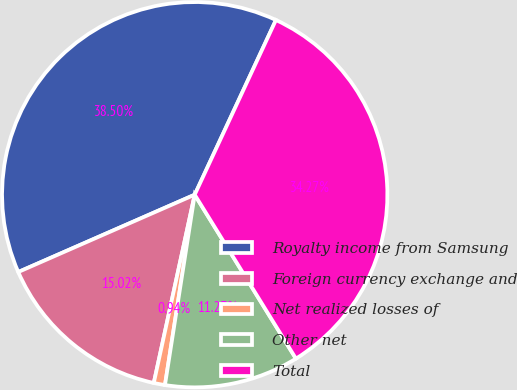Convert chart. <chart><loc_0><loc_0><loc_500><loc_500><pie_chart><fcel>Royalty income from Samsung<fcel>Foreign currency exchange and<fcel>Net realized losses of<fcel>Other net<fcel>Total<nl><fcel>38.5%<fcel>15.02%<fcel>0.94%<fcel>11.27%<fcel>34.27%<nl></chart> 